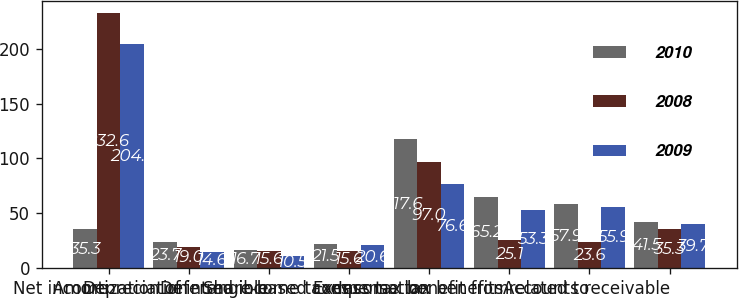Convert chart to OTSL. <chart><loc_0><loc_0><loc_500><loc_500><stacked_bar_chart><ecel><fcel>Net income<fcel>Depreciation<fcel>Amortization of intangible<fcel>Deferred income taxes<fcel>Share-based compensation<fcel>Excess tax benefit from<fcel>Income tax benefits related to<fcel>Accounts receivable<nl><fcel>2010<fcel>35.3<fcel>23.7<fcel>16.7<fcel>21.5<fcel>117.6<fcel>65.2<fcel>57.9<fcel>41.5<nl><fcel>2008<fcel>232.6<fcel>19<fcel>15.6<fcel>15.6<fcel>97<fcel>25.1<fcel>23.6<fcel>35.3<nl><fcel>2009<fcel>204.3<fcel>14.6<fcel>10.5<fcel>20.6<fcel>76.6<fcel>53.3<fcel>55.9<fcel>39.7<nl></chart> 